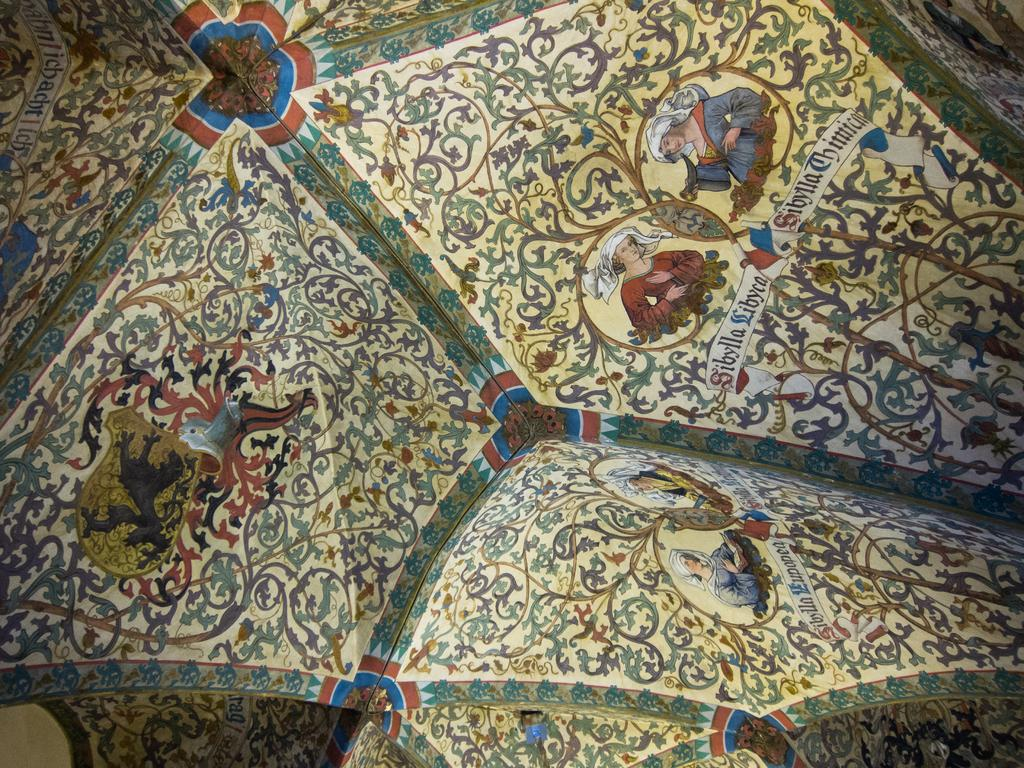What can be seen in the image? There is a design in the image, along with pictures of people. Can you describe the design in the image? Unfortunately, the description of the design is not provided in the facts. What are the people in the image doing? The facts do not specify what the people in the image are doing. What object in the image has letters on it? The facts mention that there are letters on an object in the image, but the specific object is not identified. What type of meal is being served in the image? There is no meal present in the image. What is the profit margin of the book in the image? There is no book or mention of profit in the image. 